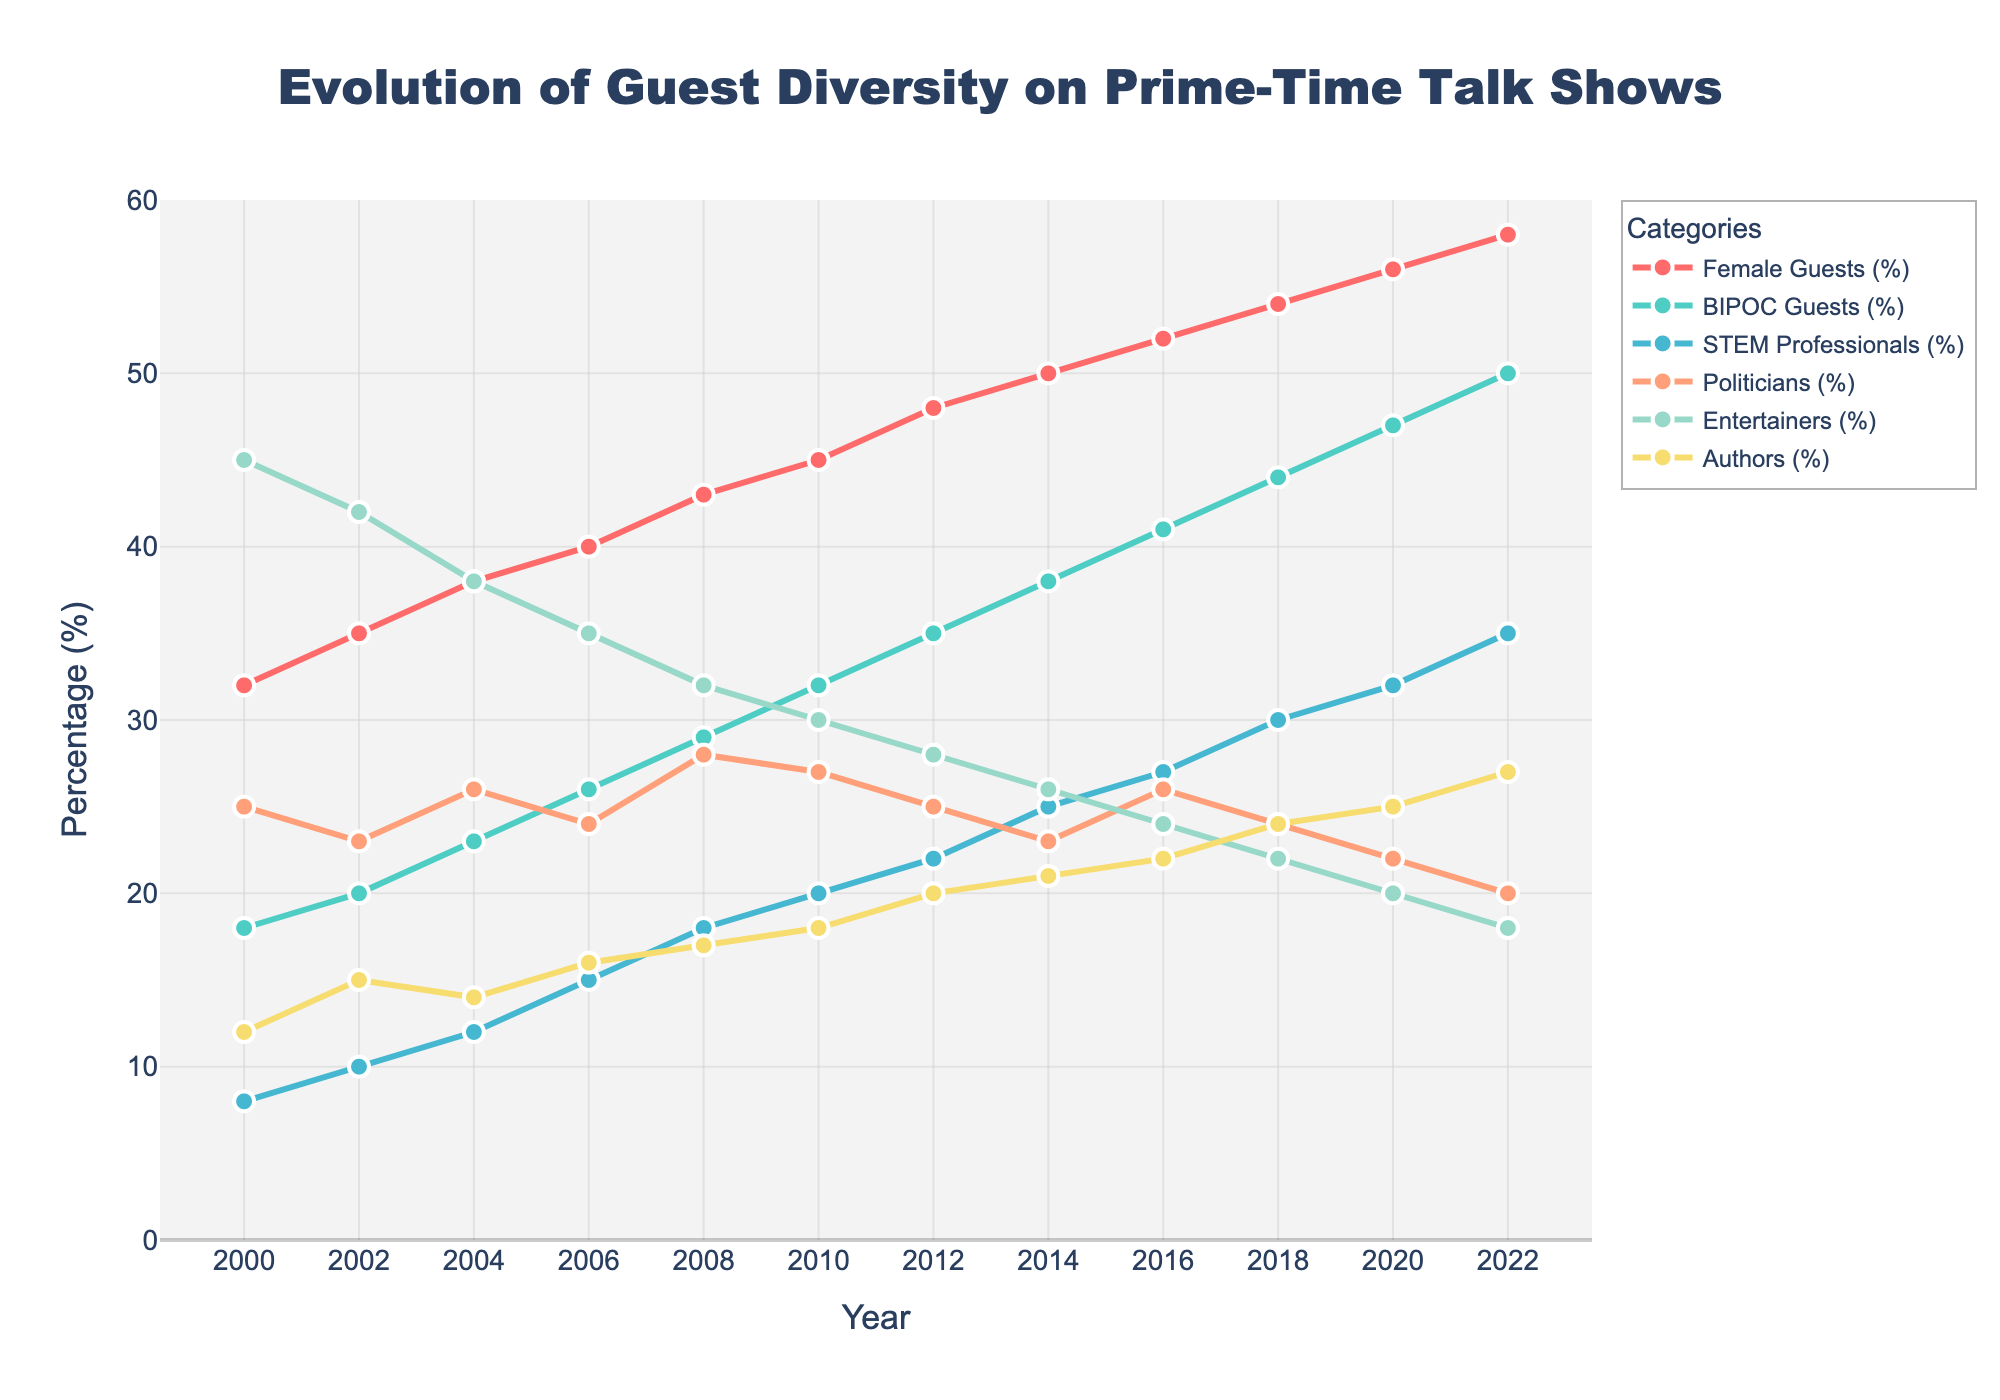what trend do you notice in the percentage of female guests from 2000 to 2022? The percentage of female guests has shown a consistent increase from 32% in 2000 to 58% in 2022.
Answer: A consistent increase Which category showed the highest percentage increase from 2000 to 2022? First, find the percentage increase for each category: 
Female Guests: 58% - 32% = 26%
BIPOC Guests: 50% - 18% = 32%
STEM Professionals: 35% - 8% = 27%
Politicians: 20% - 25% = -5%
Entertainers: 18% - 45% = -27%
Authors: 27% - 12% = 15%
The highest percentage increase is for BIPOC Guests.
Answer: BIPOC Guests In which year in the chart did the number of politicians as guests start to consistently decline? After examining the percentages year by year, we notice that the decline for politicians starts from 2012 and continues consistently.
Answer: 2012 What was the combined percentage of STEM Professionals and Authors guests in the year 2018? Add the percentages for STEM Professionals and Authors in the year 2018: 30% + 24% = 54%.
Answer: 54% Between 2004 and 2016, which category experienced the largest increase in its percentage of guests? Calculate the percentage increases:
Female Guests: 52% - 38% = 14%
BIPOC Guests: 41% - 23% = 18%
STEM Professionals: 27% - 12% = 15%
Politicians: 26% - 26% = 0%
Entertainers: 24% - 38% = -14%
Authors: 22% - 14% = 8%
The largest increase is in BIPOC Guests.
Answer: BIPOC Guests Have the percentage of Entertainers guests ever been greater than Female Guests? If yes, specify the years. Compare the percentages for each year, and we find that Entertainers had higher percentages than Female Guests from 2000 (45% vs. 32%) until 2008 (32% vs. 43%).
Answer: 2000 to 2008 On average, what percentage of guests were authors between 2008 and 2022? Calculate the average percentage:
(17%+18%+20%+21%+22%+24%+25%+27%)/8 = (174 / 8) = 21.75%
Answer: 21.75% What is the difference between the highest and the lowest percentage of BIPOC guests in the given timeline? Highest percentage of BIPOC guests is 50% in 2022 and the lowest is 18% in 2000. The difference is:
50% - 18% = 32%
Answer: 32% How does the trend of the percentage of STEM Professionals differ from that of Entertainers? The percentage of STEM Professionals has shown a consistent increase from 8% in 2000 to 35% in 2022, whereas the percentage of Entertainers has shown a consistent decrease from 45% in 2000 to 18% in 2022.
Answer: STEM Professionals increased, Entertainers decreased Which year shows the smallest decline in the percentage of Female Guests? Female Guests increased every year, so there is no year with a decline.
Answer: No decline 